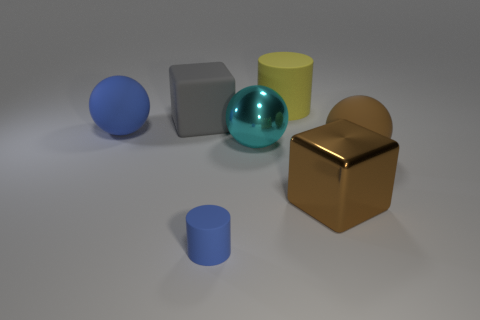Add 1 tiny blue matte things. How many objects exist? 8 Subtract all blocks. How many objects are left? 5 Subtract 0 red cubes. How many objects are left? 7 Subtract all small rubber cylinders. Subtract all big brown shiny objects. How many objects are left? 5 Add 7 large gray matte blocks. How many large gray matte blocks are left? 8 Add 4 large yellow things. How many large yellow things exist? 5 